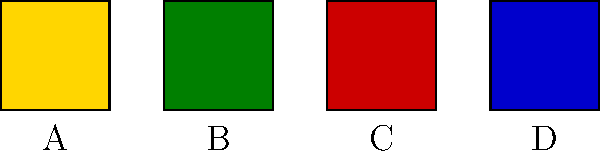In your latest novel set in West Africa, you've incorporated four traditional Adinkra symbols. Match each symbol (A, B, C, D) with its correct meaning and explain how you might use it to enhance the narrative:

1. Learning from the past
2. Strength and humility
3. Love
4. Adaptability Step 1: Identify the symbols and their meanings
A. Sankofa (gold): This symbol represents "learning from the past" or "return and get it." It's often depicted as a bird looking backward.

B. Nkyinkyim (green): This symbol represents "adaptability" or "dynamism." It's a zigzag pattern symbolizing life's twists and turns.

C. Akoma (red): This heart-shaped symbol represents "love," "patience," and "goodwill."

D. Dwennimmen (blue): This ram's horns symbol represents "strength and humility."

Step 2: Match symbols to their meanings
A - 1: Learning from the past
B - 4: Adaptability
C - 3: Love
D - 2: Strength and humility

Step 3: Explain how to use these symbols in narrative
- Sankofa: Use this symbol when characters reflect on their past or ancestral history to guide their present actions.
- Nkyinkyim: Incorporate this when characters face challenges and need to adapt to new situations.
- Akoma: Utilize this symbol in scenes involving love, compassion, or patience between characters.
- Dwennimmen: Employ this when depicting characters who show both strength and humility in their actions.

Step 4: Integrate symbols into the story
Weave these symbols into the narrative through:
- Character descriptions or tattoos
- Decorative elements in settings
- Symbolic objects or jewelry
- Chapter headings or section breaks

By incorporating these symbols, you can add depth to your story, connect it to West African cultural heritage, and provide visual cues for important themes and character development.
Answer: A-1, B-4, C-3, D-2; Use symbols for character development, setting details, and thematic reinforcement. 